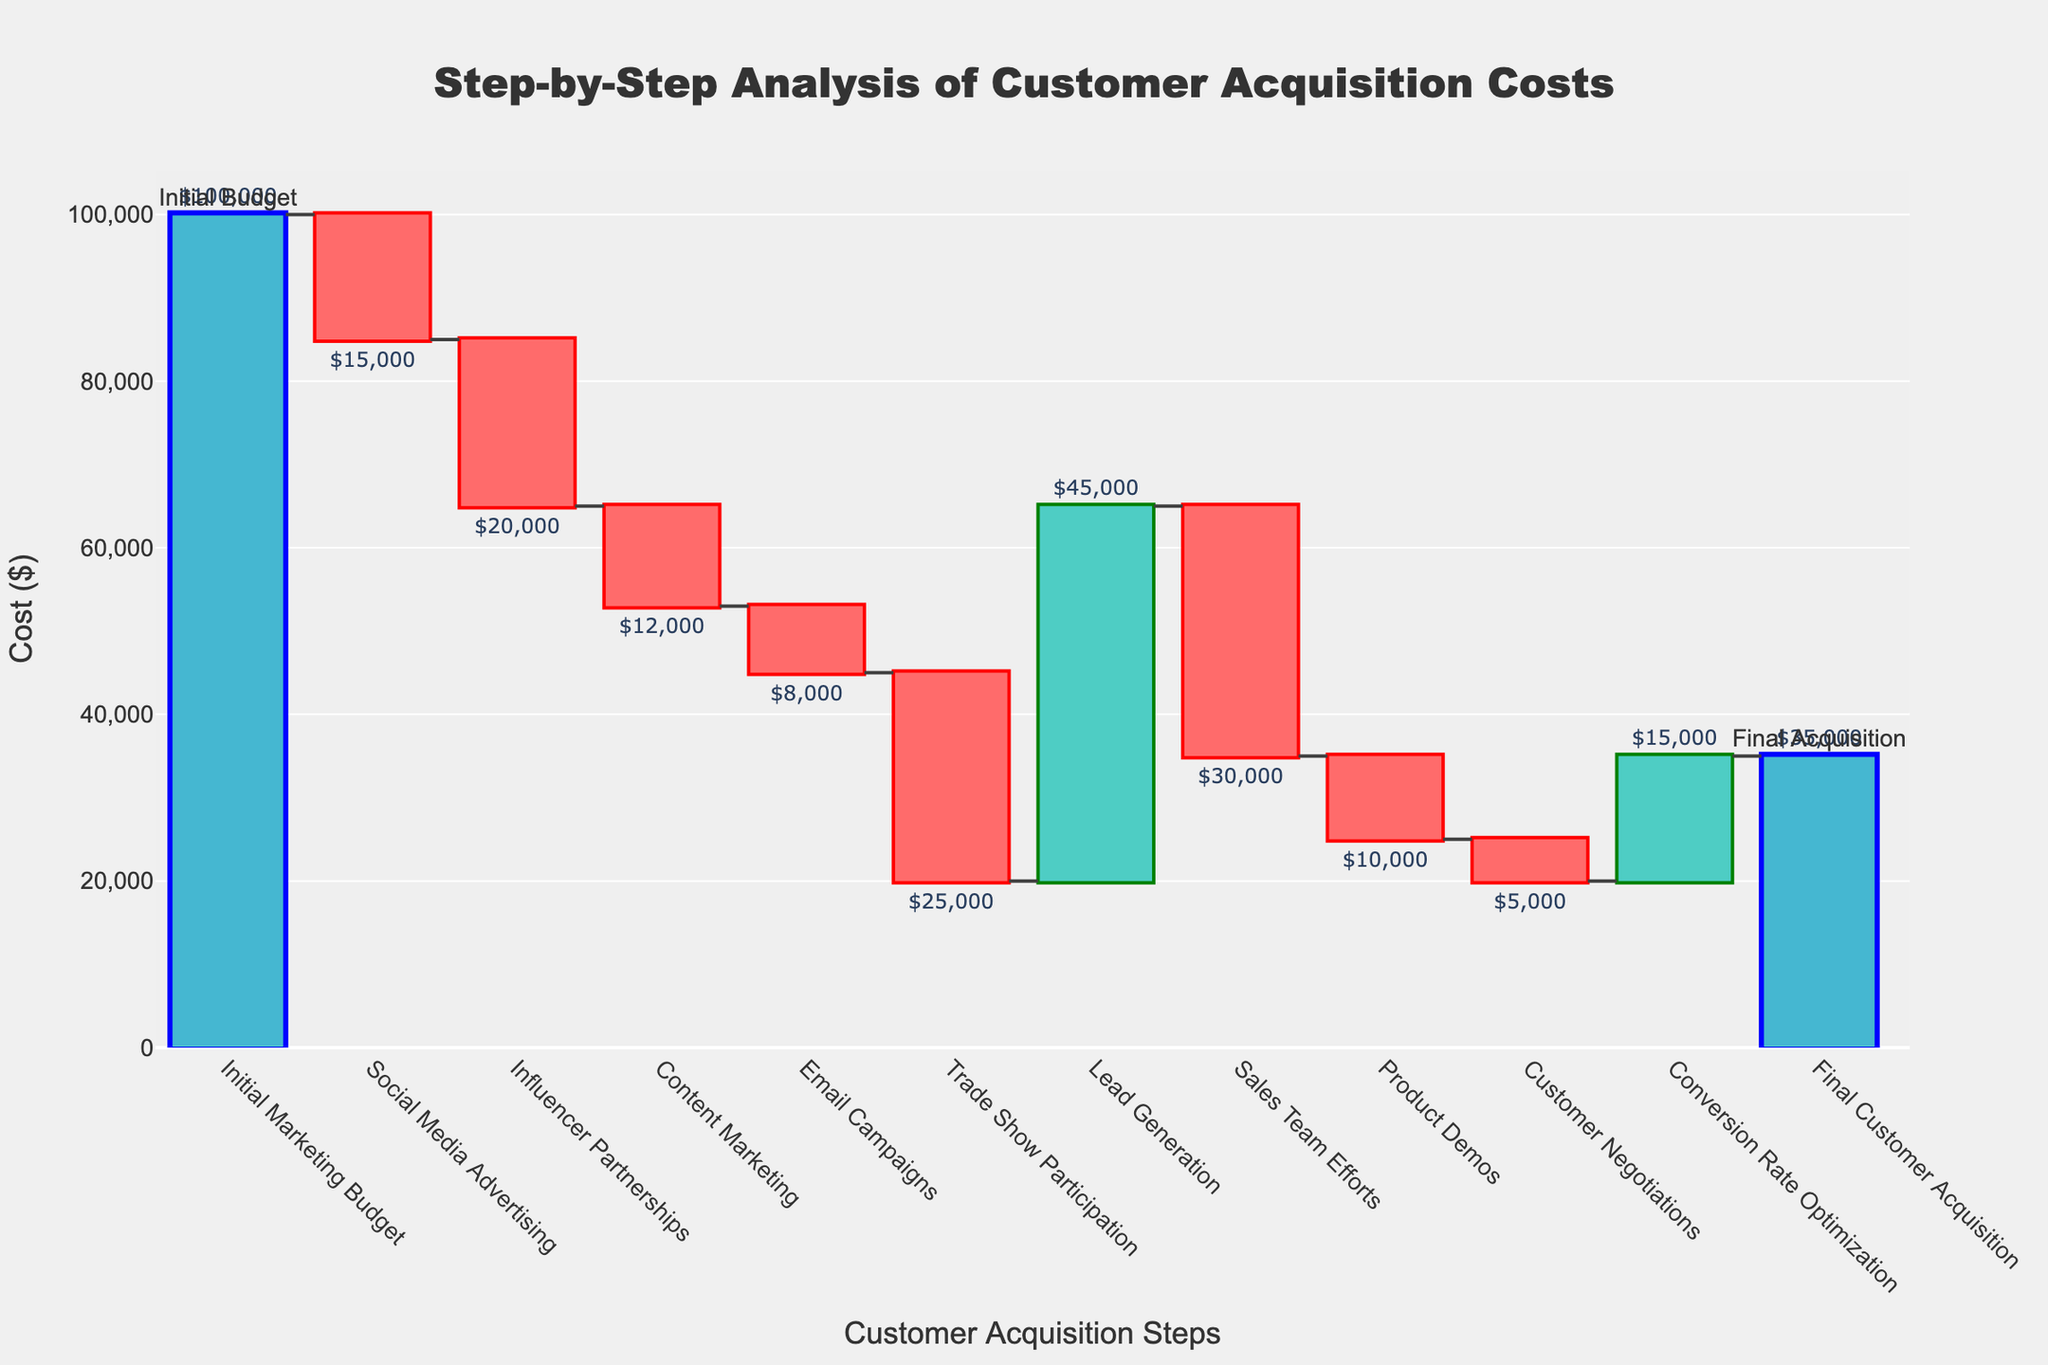What's the title of the chart? The title of the chart is located at the top center of the figure. It reads "Step-by-Step Analysis of Customer Acquisition Costs".
Answer: Step-by-Step Analysis of Customer Acquisition Costs What is the initial marketing budget? The initial marketing budget is the first bar in the chart labeled "Initial Marketing Budget". The value next to it shows the amount.
Answer: $100,000 Which step incurs the highest cost? By examining the length of the downward bars and their labels, "Trade Show Participation" shows the largest decrease.
Answer: Trade Show Participation What is the impact of lead generation on customer acquisition cost? "Lead Generation" is represented by a positive bar in the graph, which adds $45,000 to the value.
Answer: +$45,000 How much does social media advertising cost relative to influencer partnerships? By comparing the two steps, "Social Media Advertising" costs $15,000, whereas "Influencer Partnerships" costs $20,000. The difference is $5,000.
Answer: $5,000 less How much does the entire marketing budget decrease until the "Lead Generation" step? Add up the costs from "Social Media Advertising", "Influencer Partnerships", "Content Marketing", "Email Campaigns", and "Trade Show Participation". The total decrease is $15,000 + $20,000 + $12,000 + $8,000 + $25,000 = $80,000.
Answer: $80,000 What's the net change in customer acquisition cost after "Conversion Rate Optimization"? Examine the cumulative effect of values before and after "Conversion Rate Optimization". Summing up all positive and negative impacts until and including this step, we get a detailed balanced net change.
Answer: $35,000 What's the total cost reduction from "Sales Team Efforts" to "Customer Negotiations"? Sum the values of "Sales Team Efforts", "Product Demos", and "Customer Negotiations", which are $30,000 + $10,000 + $5,000. So, total reduction = $45,000.
Answer: $45,000 How does the final customer acquisition value compare to the initial marketing budget? The initial budget starts at $100,000, and the final acquisition value is $35,000. The decrease is $100,000 - $35,000 = $65,000.
Answer: $65,000 decrease 